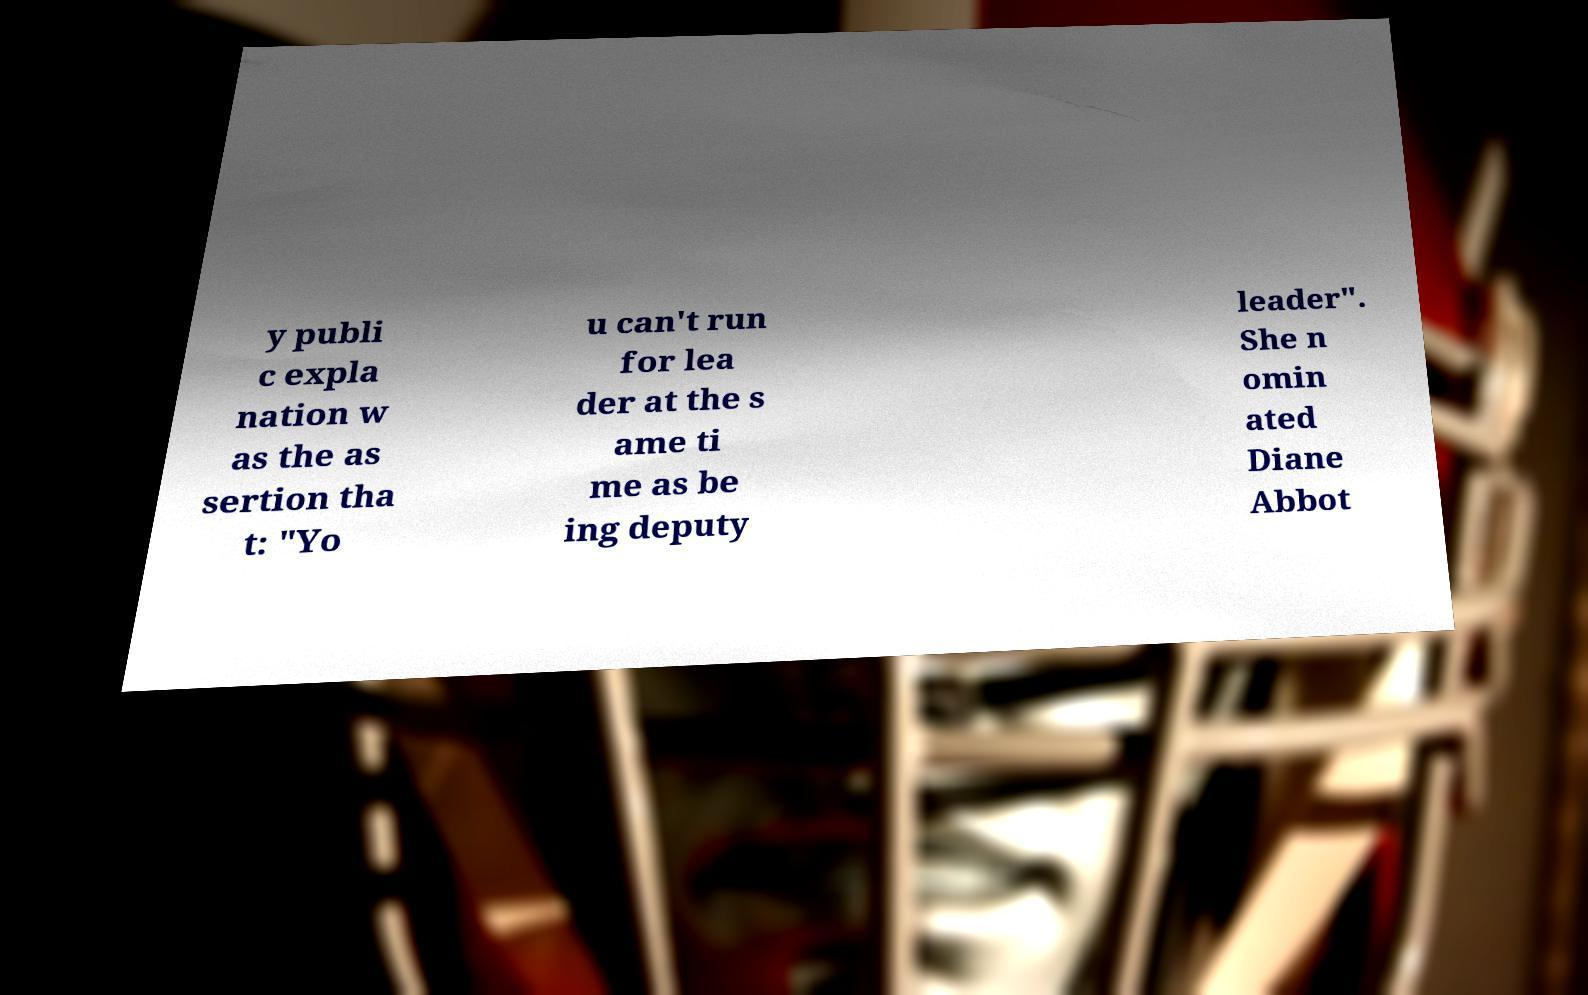Please identify and transcribe the text found in this image. y publi c expla nation w as the as sertion tha t: "Yo u can't run for lea der at the s ame ti me as be ing deputy leader". She n omin ated Diane Abbot 